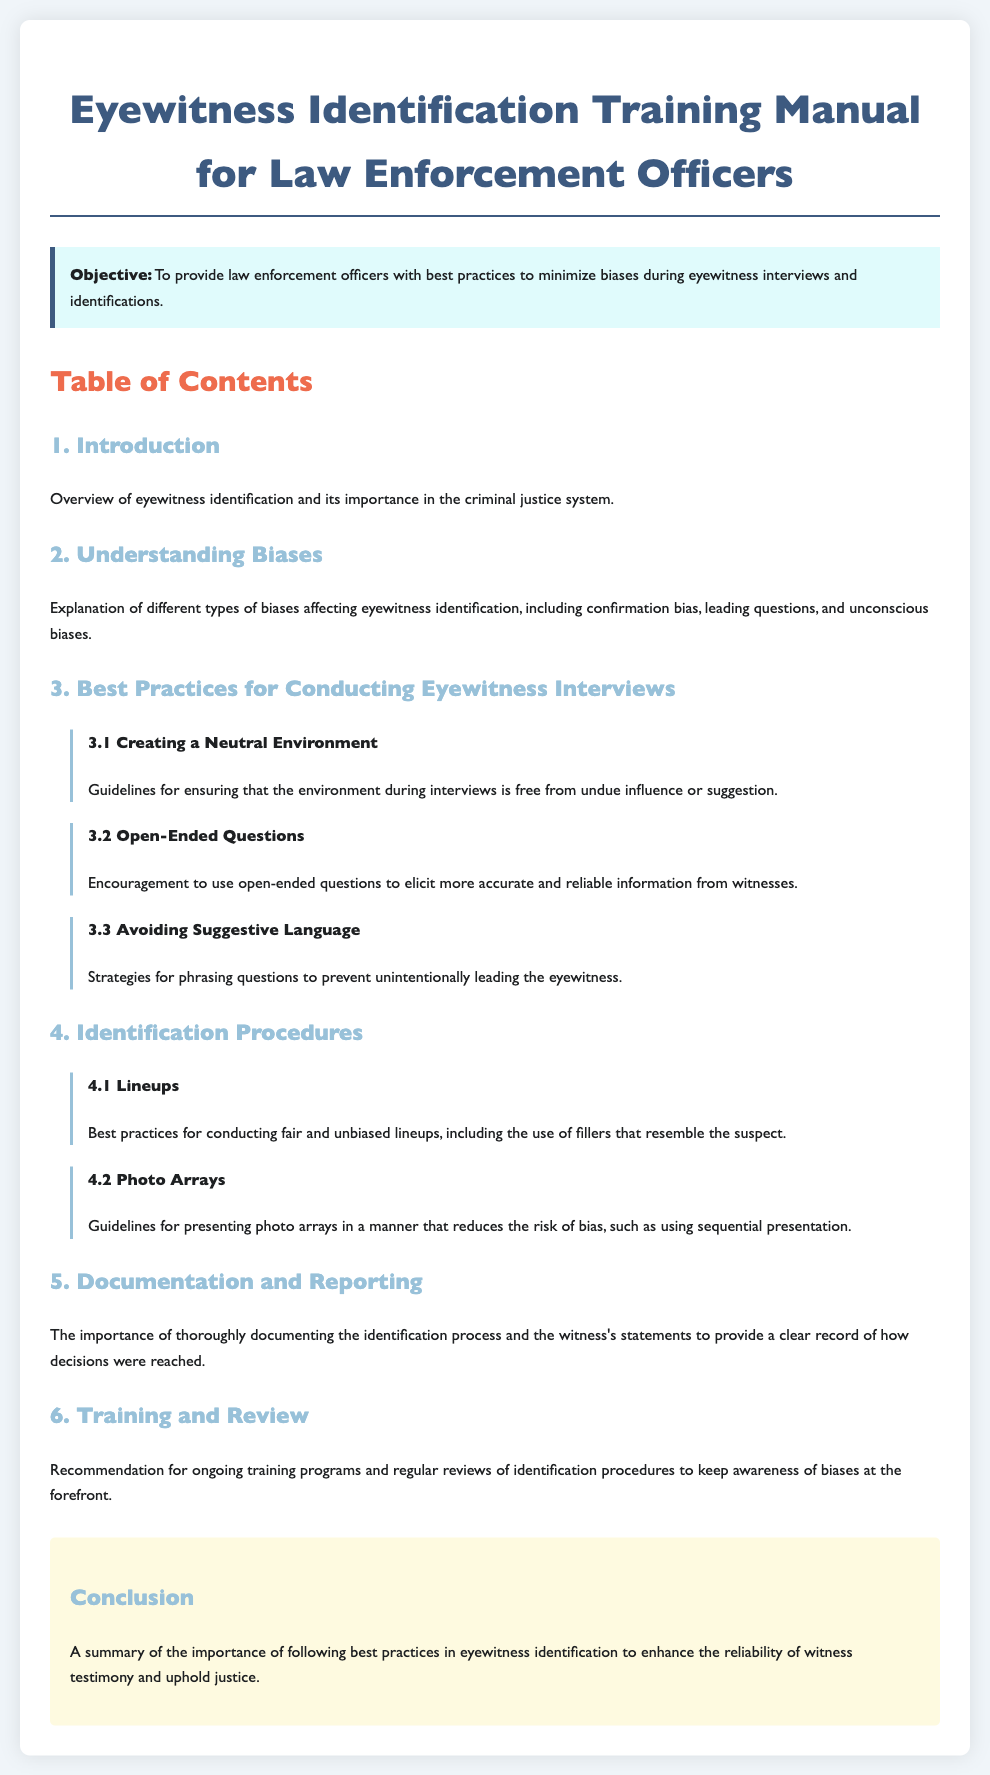what is the title of the document? The title of the document summarizes its main focus, which is "Eyewitness Identification Training Manual for Law Enforcement Officers."
Answer: Eyewitness Identification Training Manual for Law Enforcement Officers what is the objective of the manual? The objective section clearly states the purpose of the manual, which is to provide law enforcement with best practices.
Answer: To provide law enforcement officers with best practices to minimize biases during eyewitness interviews and identifications how many sections are included in the document? The document's table of contents outlines the number of sections presented, which are numbered consecutively.
Answer: Six what is one type of bias discussed in the manual? In the section about understanding biases, different types are explained, and confirmation bias is one mentioned.
Answer: Confirmation bias which practice is encouraged to elicit accurate information? The document advocates for specific questioning techniques that help gather reliable testimonies from witnesses.
Answer: Open-ended questions what is a key recommendation for identification procedures? The lineups section discusses best practices, including the necessity of using specific items in the lineup to ensure fairness.
Answer: Use of fillers that resemble the suspect where is the conclusion located within the document? The conclusion is found toward the end of the manual and summarizes the key points discussed throughout.
Answer: At the end what is the importance of documentation according to the manual? The document emphasizes the need for thorough record-keeping related to witness statements and identification processes.
Answer: To provide a clear record of how decisions were reached 